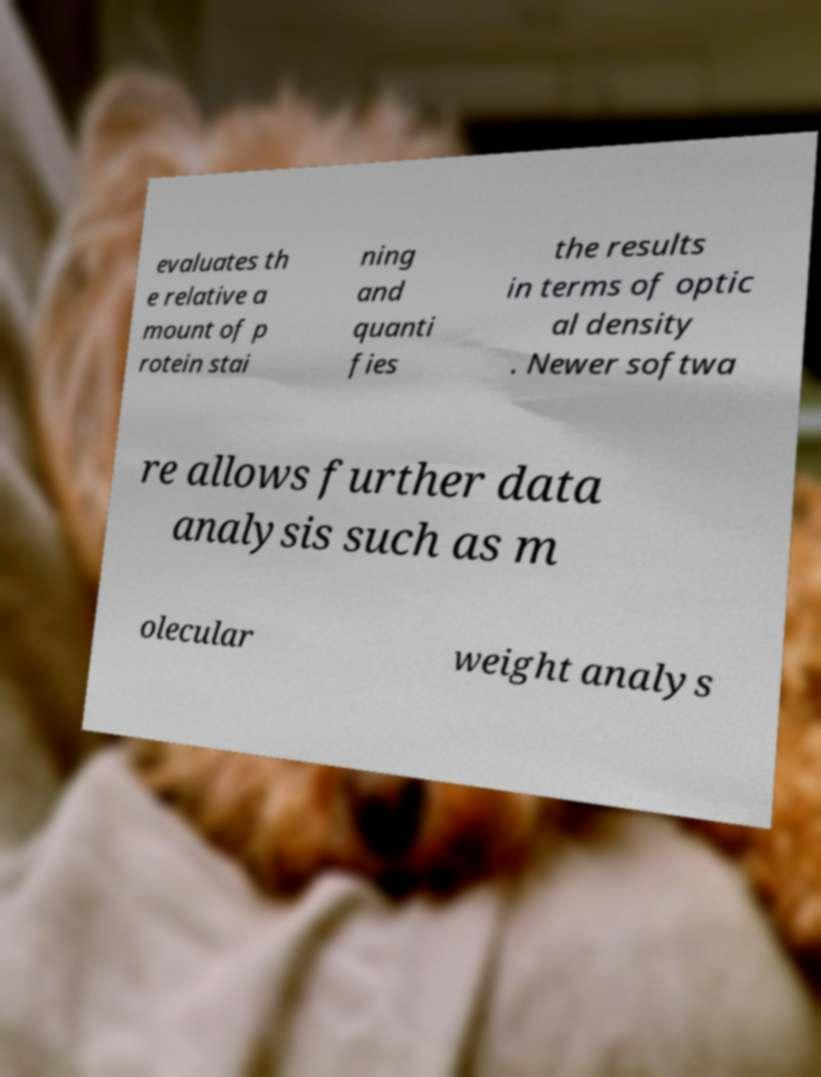Could you assist in decoding the text presented in this image and type it out clearly? evaluates th e relative a mount of p rotein stai ning and quanti fies the results in terms of optic al density . Newer softwa re allows further data analysis such as m olecular weight analys 